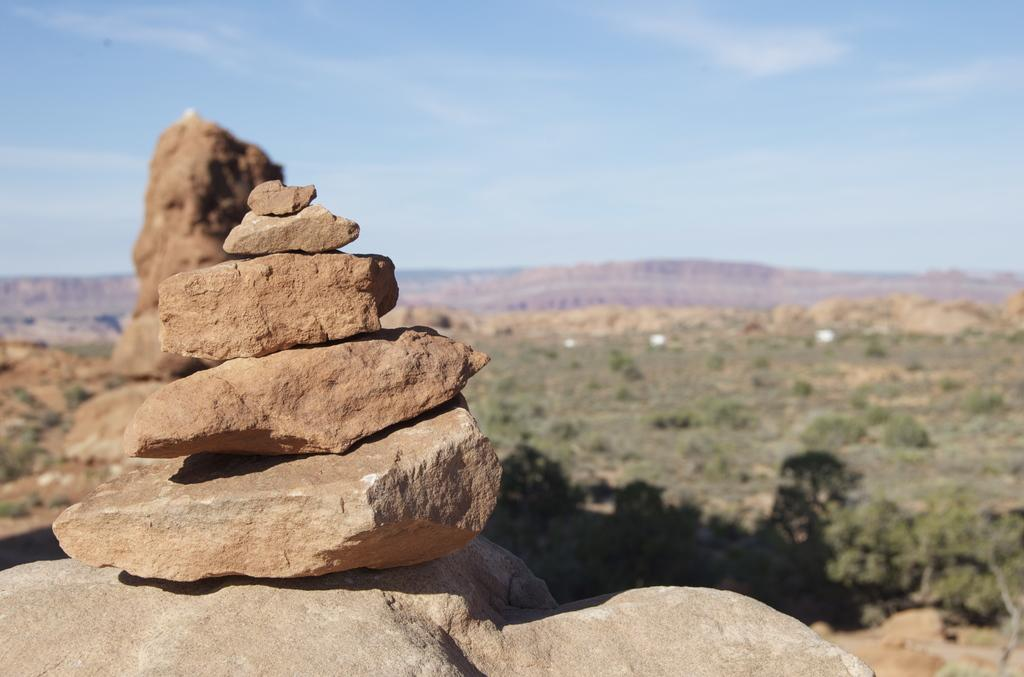What is the main geographical feature in the image? There is a mountain in the image. What type of vegetation can be seen in the image? There are trees in the image. What is located on the rock in the foreground? There are stones on a rock in the foreground. What is visible at the top of the image? The sky is visible at the top of the image. What can be seen in the sky? There are clouds in the sky. What color is the mitten that the mountain is wearing in the image? There is no mitten present in the image, as mountains do not wear mittens. 